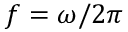Convert formula to latex. <formula><loc_0><loc_0><loc_500><loc_500>f = \omega / 2 \pi</formula> 